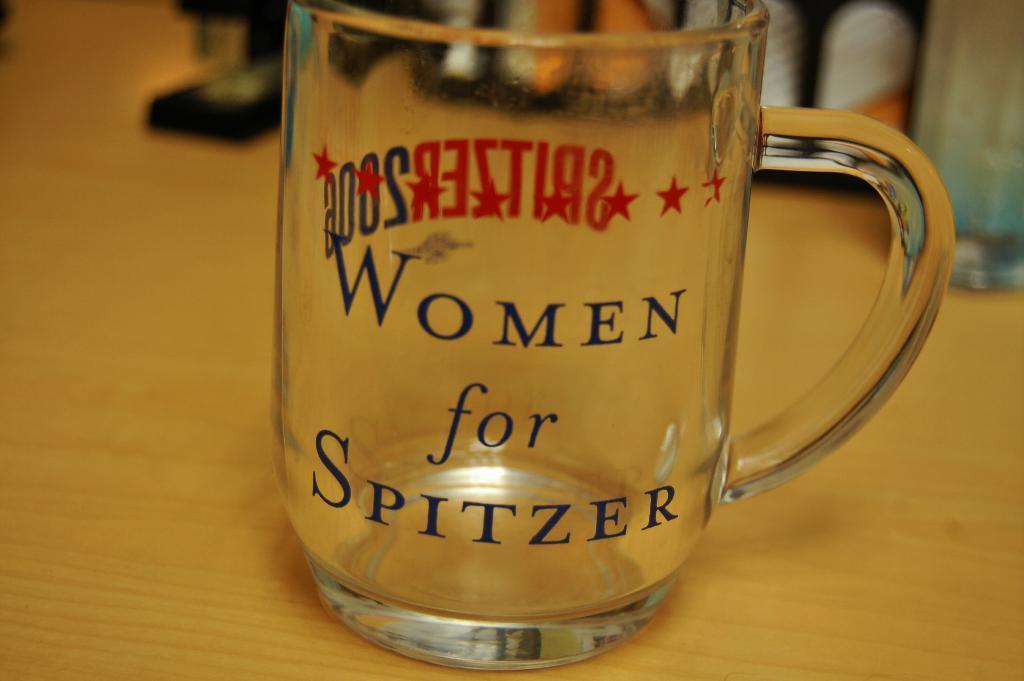Could you give a brief overview of what you see in this image? In this image i can see a cup on a table. 